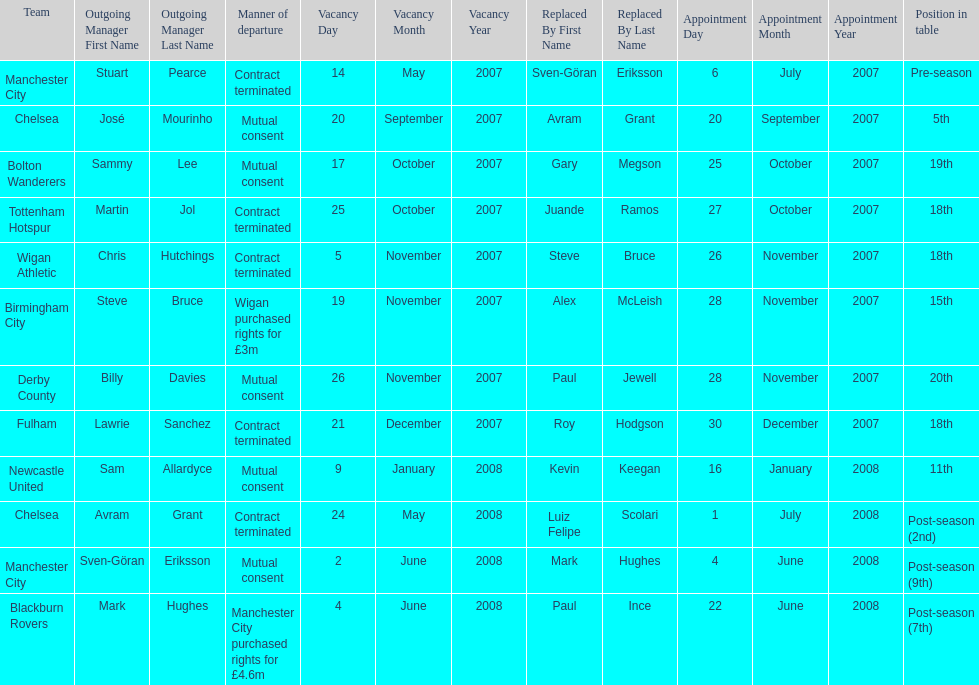Who was manager of manchester city after stuart pearce left in 2007? Sven-Göran Eriksson. 